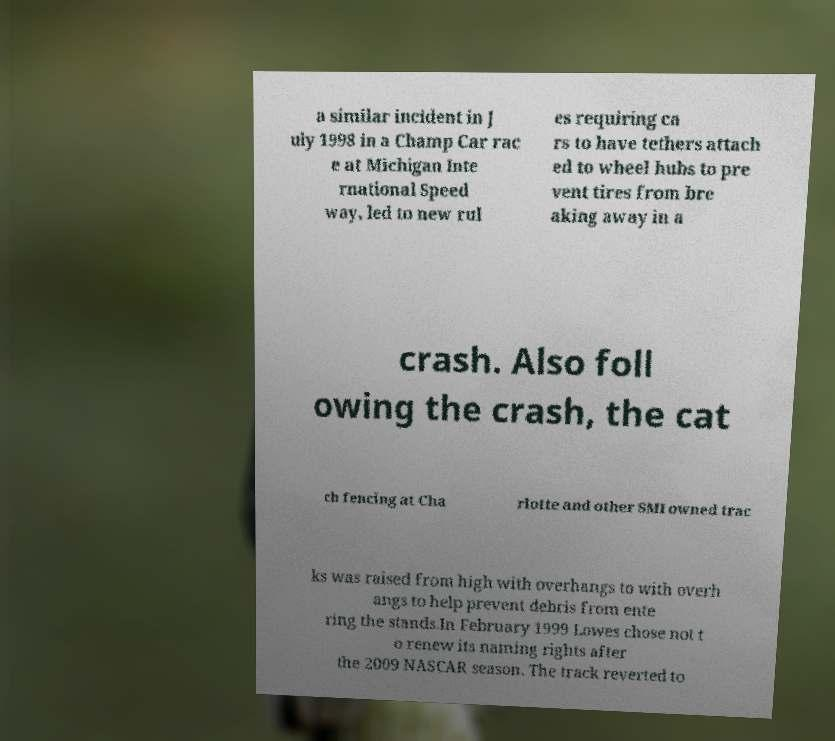Can you read and provide the text displayed in the image?This photo seems to have some interesting text. Can you extract and type it out for me? a similar incident in J uly 1998 in a Champ Car rac e at Michigan Inte rnational Speed way, led to new rul es requiring ca rs to have tethers attach ed to wheel hubs to pre vent tires from bre aking away in a crash. Also foll owing the crash, the cat ch fencing at Cha rlotte and other SMI owned trac ks was raised from high with overhangs to with overh angs to help prevent debris from ente ring the stands.In February 1999 Lowes chose not t o renew its naming rights after the 2009 NASCAR season. The track reverted to 